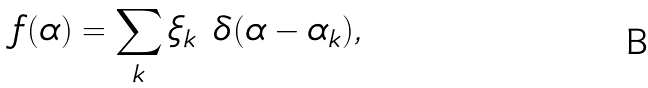<formula> <loc_0><loc_0><loc_500><loc_500>f ( \alpha ) = \sum _ { k } \xi _ { k } \ \delta ( \alpha - \alpha _ { k } ) ,</formula> 